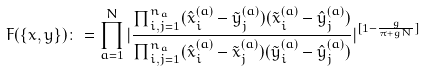Convert formula to latex. <formula><loc_0><loc_0><loc_500><loc_500>F ( \{ x , y \} ) \colon = \prod _ { a = 1 } ^ { N } | \frac { \prod _ { i , j = 1 } ^ { n _ { a } } ( \hat { x } _ { i } ^ { ( a ) } - \tilde { y } _ { j } ^ { ( a ) } ) ( \tilde { x } _ { i } ^ { ( a ) } - \hat { y } _ { j } ^ { ( a ) } ) } { \prod _ { i , j = 1 } ^ { n _ { a } } ( \hat { x } _ { i } ^ { ( a ) } - \tilde { x } _ { j } ^ { ( a ) } ) ( \tilde { y } _ { i } ^ { ( a ) } - \hat { y } _ { j } ^ { ( a ) } ) } | ^ { [ 1 - \frac { g } { \pi + g N } ] }</formula> 